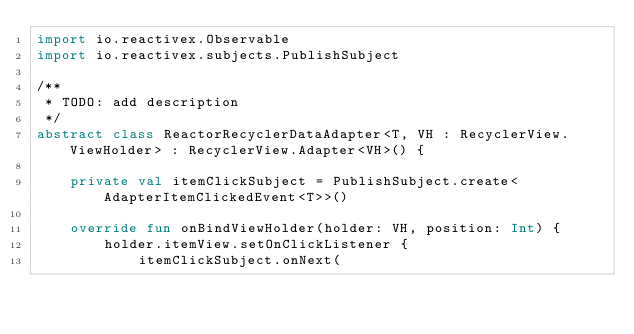Convert code to text. <code><loc_0><loc_0><loc_500><loc_500><_Kotlin_>import io.reactivex.Observable
import io.reactivex.subjects.PublishSubject

/**
 * TODO: add description
 */
abstract class ReactorRecyclerDataAdapter<T, VH : RecyclerView.ViewHolder> : RecyclerView.Adapter<VH>() {

    private val itemClickSubject = PublishSubject.create<AdapterItemClickedEvent<T>>()

    override fun onBindViewHolder(holder: VH, position: Int) {
        holder.itemView.setOnClickListener {
            itemClickSubject.onNext(</code> 